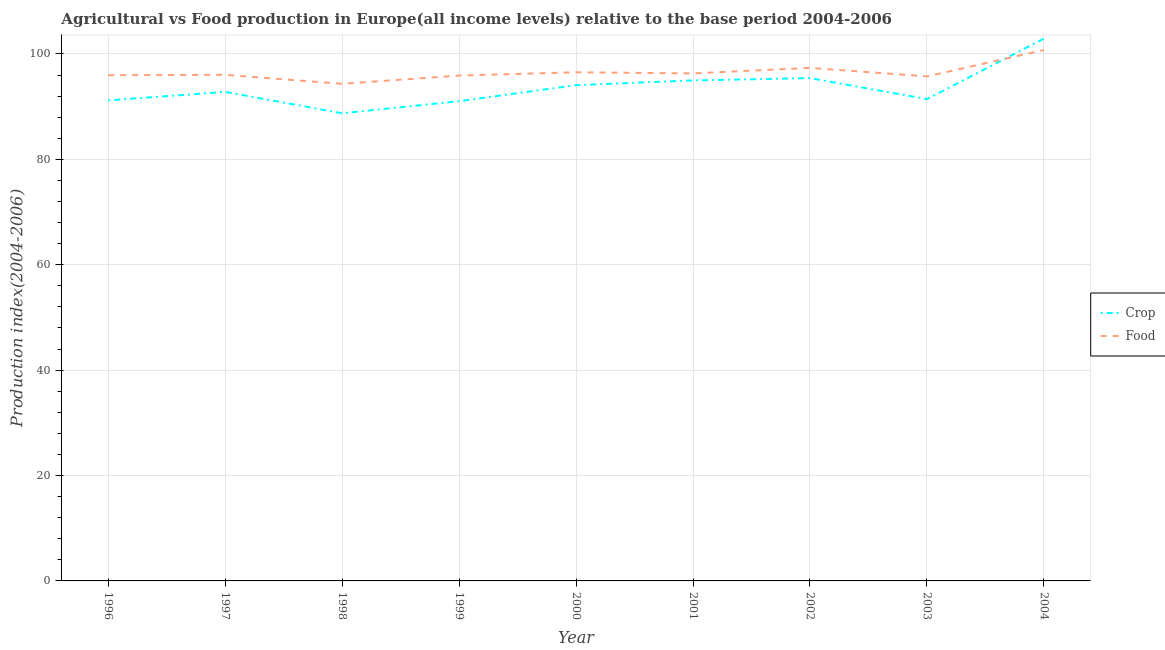How many different coloured lines are there?
Provide a short and direct response. 2. What is the food production index in 1996?
Ensure brevity in your answer.  95.96. Across all years, what is the maximum crop production index?
Give a very brief answer. 102.91. Across all years, what is the minimum food production index?
Provide a succinct answer. 94.32. What is the total food production index in the graph?
Your answer should be very brief. 868.87. What is the difference between the food production index in 1996 and that in 2004?
Keep it short and to the point. -4.79. What is the difference between the crop production index in 2001 and the food production index in 1999?
Offer a terse response. -0.92. What is the average food production index per year?
Offer a very short reply. 96.54. In the year 2004, what is the difference between the crop production index and food production index?
Ensure brevity in your answer.  2.16. In how many years, is the crop production index greater than 36?
Make the answer very short. 9. What is the ratio of the crop production index in 2001 to that in 2002?
Keep it short and to the point. 1. Is the food production index in 1996 less than that in 2002?
Make the answer very short. Yes. Is the difference between the crop production index in 1999 and 2000 greater than the difference between the food production index in 1999 and 2000?
Your answer should be very brief. No. What is the difference between the highest and the second highest food production index?
Your answer should be very brief. 3.39. What is the difference between the highest and the lowest crop production index?
Your answer should be compact. 14.17. In how many years, is the food production index greater than the average food production index taken over all years?
Your answer should be compact. 2. Does the crop production index monotonically increase over the years?
Your answer should be compact. No. Is the crop production index strictly less than the food production index over the years?
Provide a succinct answer. No. How many lines are there?
Your answer should be compact. 2. What is the difference between two consecutive major ticks on the Y-axis?
Provide a succinct answer. 20. Does the graph contain any zero values?
Make the answer very short. No. Does the graph contain grids?
Offer a terse response. Yes. How are the legend labels stacked?
Ensure brevity in your answer.  Vertical. What is the title of the graph?
Your answer should be compact. Agricultural vs Food production in Europe(all income levels) relative to the base period 2004-2006. Does "Long-term debt" appear as one of the legend labels in the graph?
Your response must be concise. No. What is the label or title of the X-axis?
Give a very brief answer. Year. What is the label or title of the Y-axis?
Ensure brevity in your answer.  Production index(2004-2006). What is the Production index(2004-2006) of Crop in 1996?
Make the answer very short. 91.18. What is the Production index(2004-2006) of Food in 1996?
Your answer should be very brief. 95.96. What is the Production index(2004-2006) in Crop in 1997?
Provide a short and direct response. 92.79. What is the Production index(2004-2006) in Food in 1997?
Make the answer very short. 96.04. What is the Production index(2004-2006) in Crop in 1998?
Your answer should be very brief. 88.74. What is the Production index(2004-2006) of Food in 1998?
Provide a short and direct response. 94.32. What is the Production index(2004-2006) in Crop in 1999?
Ensure brevity in your answer.  91.03. What is the Production index(2004-2006) in Food in 1999?
Keep it short and to the point. 95.89. What is the Production index(2004-2006) in Crop in 2000?
Provide a short and direct response. 94.07. What is the Production index(2004-2006) in Food in 2000?
Your answer should be compact. 96.52. What is the Production index(2004-2006) in Crop in 2001?
Your response must be concise. 94.97. What is the Production index(2004-2006) in Food in 2001?
Make the answer very short. 96.3. What is the Production index(2004-2006) in Crop in 2002?
Your answer should be very brief. 95.41. What is the Production index(2004-2006) in Food in 2002?
Provide a short and direct response. 97.35. What is the Production index(2004-2006) in Crop in 2003?
Your answer should be compact. 91.42. What is the Production index(2004-2006) in Food in 2003?
Offer a very short reply. 95.74. What is the Production index(2004-2006) of Crop in 2004?
Provide a short and direct response. 102.91. What is the Production index(2004-2006) of Food in 2004?
Ensure brevity in your answer.  100.75. Across all years, what is the maximum Production index(2004-2006) in Crop?
Make the answer very short. 102.91. Across all years, what is the maximum Production index(2004-2006) in Food?
Provide a succinct answer. 100.75. Across all years, what is the minimum Production index(2004-2006) in Crop?
Keep it short and to the point. 88.74. Across all years, what is the minimum Production index(2004-2006) of Food?
Offer a very short reply. 94.32. What is the total Production index(2004-2006) of Crop in the graph?
Offer a very short reply. 842.54. What is the total Production index(2004-2006) of Food in the graph?
Your answer should be compact. 868.87. What is the difference between the Production index(2004-2006) in Crop in 1996 and that in 1997?
Provide a short and direct response. -1.61. What is the difference between the Production index(2004-2006) in Food in 1996 and that in 1997?
Provide a succinct answer. -0.08. What is the difference between the Production index(2004-2006) in Crop in 1996 and that in 1998?
Provide a short and direct response. 2.44. What is the difference between the Production index(2004-2006) of Food in 1996 and that in 1998?
Provide a succinct answer. 1.64. What is the difference between the Production index(2004-2006) in Crop in 1996 and that in 1999?
Make the answer very short. 0.15. What is the difference between the Production index(2004-2006) in Food in 1996 and that in 1999?
Your answer should be very brief. 0.07. What is the difference between the Production index(2004-2006) of Crop in 1996 and that in 2000?
Provide a short and direct response. -2.89. What is the difference between the Production index(2004-2006) in Food in 1996 and that in 2000?
Keep it short and to the point. -0.56. What is the difference between the Production index(2004-2006) in Crop in 1996 and that in 2001?
Ensure brevity in your answer.  -3.79. What is the difference between the Production index(2004-2006) of Food in 1996 and that in 2001?
Give a very brief answer. -0.34. What is the difference between the Production index(2004-2006) of Crop in 1996 and that in 2002?
Make the answer very short. -4.23. What is the difference between the Production index(2004-2006) in Food in 1996 and that in 2002?
Provide a short and direct response. -1.39. What is the difference between the Production index(2004-2006) of Crop in 1996 and that in 2003?
Provide a short and direct response. -0.24. What is the difference between the Production index(2004-2006) of Food in 1996 and that in 2003?
Provide a succinct answer. 0.22. What is the difference between the Production index(2004-2006) in Crop in 1996 and that in 2004?
Provide a succinct answer. -11.72. What is the difference between the Production index(2004-2006) of Food in 1996 and that in 2004?
Provide a succinct answer. -4.79. What is the difference between the Production index(2004-2006) in Crop in 1997 and that in 1998?
Offer a very short reply. 4.05. What is the difference between the Production index(2004-2006) of Food in 1997 and that in 1998?
Provide a short and direct response. 1.71. What is the difference between the Production index(2004-2006) in Crop in 1997 and that in 1999?
Keep it short and to the point. 1.76. What is the difference between the Production index(2004-2006) of Food in 1997 and that in 1999?
Your answer should be very brief. 0.14. What is the difference between the Production index(2004-2006) in Crop in 1997 and that in 2000?
Offer a very short reply. -1.28. What is the difference between the Production index(2004-2006) of Food in 1997 and that in 2000?
Your answer should be compact. -0.48. What is the difference between the Production index(2004-2006) of Crop in 1997 and that in 2001?
Give a very brief answer. -2.18. What is the difference between the Production index(2004-2006) in Food in 1997 and that in 2001?
Offer a terse response. -0.27. What is the difference between the Production index(2004-2006) in Crop in 1997 and that in 2002?
Your answer should be very brief. -2.62. What is the difference between the Production index(2004-2006) in Food in 1997 and that in 2002?
Provide a short and direct response. -1.31. What is the difference between the Production index(2004-2006) in Crop in 1997 and that in 2003?
Give a very brief answer. 1.37. What is the difference between the Production index(2004-2006) in Food in 1997 and that in 2003?
Your response must be concise. 0.3. What is the difference between the Production index(2004-2006) in Crop in 1997 and that in 2004?
Ensure brevity in your answer.  -10.11. What is the difference between the Production index(2004-2006) in Food in 1997 and that in 2004?
Provide a succinct answer. -4.71. What is the difference between the Production index(2004-2006) in Crop in 1998 and that in 1999?
Your response must be concise. -2.29. What is the difference between the Production index(2004-2006) of Food in 1998 and that in 1999?
Your answer should be very brief. -1.57. What is the difference between the Production index(2004-2006) of Crop in 1998 and that in 2000?
Your answer should be compact. -5.33. What is the difference between the Production index(2004-2006) in Food in 1998 and that in 2000?
Your response must be concise. -2.19. What is the difference between the Production index(2004-2006) in Crop in 1998 and that in 2001?
Offer a terse response. -6.23. What is the difference between the Production index(2004-2006) of Food in 1998 and that in 2001?
Offer a very short reply. -1.98. What is the difference between the Production index(2004-2006) of Crop in 1998 and that in 2002?
Make the answer very short. -6.67. What is the difference between the Production index(2004-2006) of Food in 1998 and that in 2002?
Give a very brief answer. -3.03. What is the difference between the Production index(2004-2006) in Crop in 1998 and that in 2003?
Your answer should be very brief. -2.68. What is the difference between the Production index(2004-2006) of Food in 1998 and that in 2003?
Offer a very short reply. -1.41. What is the difference between the Production index(2004-2006) in Crop in 1998 and that in 2004?
Your response must be concise. -14.17. What is the difference between the Production index(2004-2006) of Food in 1998 and that in 2004?
Provide a short and direct response. -6.42. What is the difference between the Production index(2004-2006) of Crop in 1999 and that in 2000?
Keep it short and to the point. -3.04. What is the difference between the Production index(2004-2006) in Food in 1999 and that in 2000?
Provide a succinct answer. -0.62. What is the difference between the Production index(2004-2006) in Crop in 1999 and that in 2001?
Make the answer very short. -3.94. What is the difference between the Production index(2004-2006) of Food in 1999 and that in 2001?
Ensure brevity in your answer.  -0.41. What is the difference between the Production index(2004-2006) of Crop in 1999 and that in 2002?
Your response must be concise. -4.38. What is the difference between the Production index(2004-2006) of Food in 1999 and that in 2002?
Provide a succinct answer. -1.46. What is the difference between the Production index(2004-2006) in Crop in 1999 and that in 2003?
Give a very brief answer. -0.39. What is the difference between the Production index(2004-2006) of Food in 1999 and that in 2003?
Ensure brevity in your answer.  0.16. What is the difference between the Production index(2004-2006) in Crop in 1999 and that in 2004?
Ensure brevity in your answer.  -11.87. What is the difference between the Production index(2004-2006) of Food in 1999 and that in 2004?
Give a very brief answer. -4.85. What is the difference between the Production index(2004-2006) of Crop in 2000 and that in 2001?
Give a very brief answer. -0.9. What is the difference between the Production index(2004-2006) of Food in 2000 and that in 2001?
Ensure brevity in your answer.  0.21. What is the difference between the Production index(2004-2006) in Crop in 2000 and that in 2002?
Ensure brevity in your answer.  -1.34. What is the difference between the Production index(2004-2006) of Food in 2000 and that in 2002?
Ensure brevity in your answer.  -0.83. What is the difference between the Production index(2004-2006) in Crop in 2000 and that in 2003?
Give a very brief answer. 2.65. What is the difference between the Production index(2004-2006) of Food in 2000 and that in 2003?
Offer a terse response. 0.78. What is the difference between the Production index(2004-2006) of Crop in 2000 and that in 2004?
Your response must be concise. -8.84. What is the difference between the Production index(2004-2006) in Food in 2000 and that in 2004?
Provide a short and direct response. -4.23. What is the difference between the Production index(2004-2006) in Crop in 2001 and that in 2002?
Your answer should be very brief. -0.44. What is the difference between the Production index(2004-2006) of Food in 2001 and that in 2002?
Your response must be concise. -1.05. What is the difference between the Production index(2004-2006) of Crop in 2001 and that in 2003?
Give a very brief answer. 3.55. What is the difference between the Production index(2004-2006) of Food in 2001 and that in 2003?
Make the answer very short. 0.57. What is the difference between the Production index(2004-2006) of Crop in 2001 and that in 2004?
Your response must be concise. -7.93. What is the difference between the Production index(2004-2006) of Food in 2001 and that in 2004?
Offer a very short reply. -4.44. What is the difference between the Production index(2004-2006) in Crop in 2002 and that in 2003?
Provide a short and direct response. 3.99. What is the difference between the Production index(2004-2006) in Food in 2002 and that in 2003?
Provide a succinct answer. 1.62. What is the difference between the Production index(2004-2006) in Crop in 2002 and that in 2004?
Offer a terse response. -7.5. What is the difference between the Production index(2004-2006) of Food in 2002 and that in 2004?
Your response must be concise. -3.39. What is the difference between the Production index(2004-2006) of Crop in 2003 and that in 2004?
Provide a succinct answer. -11.48. What is the difference between the Production index(2004-2006) in Food in 2003 and that in 2004?
Your answer should be compact. -5.01. What is the difference between the Production index(2004-2006) of Crop in 1996 and the Production index(2004-2006) of Food in 1997?
Your answer should be compact. -4.85. What is the difference between the Production index(2004-2006) of Crop in 1996 and the Production index(2004-2006) of Food in 1998?
Provide a succinct answer. -3.14. What is the difference between the Production index(2004-2006) of Crop in 1996 and the Production index(2004-2006) of Food in 1999?
Make the answer very short. -4.71. What is the difference between the Production index(2004-2006) of Crop in 1996 and the Production index(2004-2006) of Food in 2000?
Offer a terse response. -5.33. What is the difference between the Production index(2004-2006) of Crop in 1996 and the Production index(2004-2006) of Food in 2001?
Your response must be concise. -5.12. What is the difference between the Production index(2004-2006) in Crop in 1996 and the Production index(2004-2006) in Food in 2002?
Make the answer very short. -6.17. What is the difference between the Production index(2004-2006) in Crop in 1996 and the Production index(2004-2006) in Food in 2003?
Provide a succinct answer. -4.55. What is the difference between the Production index(2004-2006) of Crop in 1996 and the Production index(2004-2006) of Food in 2004?
Offer a very short reply. -9.56. What is the difference between the Production index(2004-2006) of Crop in 1997 and the Production index(2004-2006) of Food in 1998?
Offer a terse response. -1.53. What is the difference between the Production index(2004-2006) in Crop in 1997 and the Production index(2004-2006) in Food in 1999?
Provide a succinct answer. -3.1. What is the difference between the Production index(2004-2006) of Crop in 1997 and the Production index(2004-2006) of Food in 2000?
Keep it short and to the point. -3.72. What is the difference between the Production index(2004-2006) in Crop in 1997 and the Production index(2004-2006) in Food in 2001?
Keep it short and to the point. -3.51. What is the difference between the Production index(2004-2006) of Crop in 1997 and the Production index(2004-2006) of Food in 2002?
Your response must be concise. -4.56. What is the difference between the Production index(2004-2006) of Crop in 1997 and the Production index(2004-2006) of Food in 2003?
Your answer should be very brief. -2.94. What is the difference between the Production index(2004-2006) in Crop in 1997 and the Production index(2004-2006) in Food in 2004?
Give a very brief answer. -7.95. What is the difference between the Production index(2004-2006) in Crop in 1998 and the Production index(2004-2006) in Food in 1999?
Ensure brevity in your answer.  -7.15. What is the difference between the Production index(2004-2006) of Crop in 1998 and the Production index(2004-2006) of Food in 2000?
Your answer should be compact. -7.78. What is the difference between the Production index(2004-2006) of Crop in 1998 and the Production index(2004-2006) of Food in 2001?
Keep it short and to the point. -7.56. What is the difference between the Production index(2004-2006) of Crop in 1998 and the Production index(2004-2006) of Food in 2002?
Offer a terse response. -8.61. What is the difference between the Production index(2004-2006) of Crop in 1998 and the Production index(2004-2006) of Food in 2003?
Your answer should be compact. -7. What is the difference between the Production index(2004-2006) in Crop in 1998 and the Production index(2004-2006) in Food in 2004?
Give a very brief answer. -12.01. What is the difference between the Production index(2004-2006) in Crop in 1999 and the Production index(2004-2006) in Food in 2000?
Your response must be concise. -5.49. What is the difference between the Production index(2004-2006) in Crop in 1999 and the Production index(2004-2006) in Food in 2001?
Give a very brief answer. -5.27. What is the difference between the Production index(2004-2006) of Crop in 1999 and the Production index(2004-2006) of Food in 2002?
Make the answer very short. -6.32. What is the difference between the Production index(2004-2006) of Crop in 1999 and the Production index(2004-2006) of Food in 2003?
Give a very brief answer. -4.7. What is the difference between the Production index(2004-2006) in Crop in 1999 and the Production index(2004-2006) in Food in 2004?
Keep it short and to the point. -9.71. What is the difference between the Production index(2004-2006) of Crop in 2000 and the Production index(2004-2006) of Food in 2001?
Your answer should be very brief. -2.23. What is the difference between the Production index(2004-2006) of Crop in 2000 and the Production index(2004-2006) of Food in 2002?
Make the answer very short. -3.28. What is the difference between the Production index(2004-2006) in Crop in 2000 and the Production index(2004-2006) in Food in 2003?
Ensure brevity in your answer.  -1.66. What is the difference between the Production index(2004-2006) in Crop in 2000 and the Production index(2004-2006) in Food in 2004?
Your answer should be compact. -6.67. What is the difference between the Production index(2004-2006) in Crop in 2001 and the Production index(2004-2006) in Food in 2002?
Your answer should be very brief. -2.38. What is the difference between the Production index(2004-2006) in Crop in 2001 and the Production index(2004-2006) in Food in 2003?
Offer a terse response. -0.76. What is the difference between the Production index(2004-2006) of Crop in 2001 and the Production index(2004-2006) of Food in 2004?
Make the answer very short. -5.77. What is the difference between the Production index(2004-2006) of Crop in 2002 and the Production index(2004-2006) of Food in 2003?
Offer a terse response. -0.32. What is the difference between the Production index(2004-2006) of Crop in 2002 and the Production index(2004-2006) of Food in 2004?
Your answer should be very brief. -5.33. What is the difference between the Production index(2004-2006) in Crop in 2003 and the Production index(2004-2006) in Food in 2004?
Give a very brief answer. -9.32. What is the average Production index(2004-2006) in Crop per year?
Offer a very short reply. 93.62. What is the average Production index(2004-2006) in Food per year?
Give a very brief answer. 96.54. In the year 1996, what is the difference between the Production index(2004-2006) in Crop and Production index(2004-2006) in Food?
Offer a terse response. -4.78. In the year 1997, what is the difference between the Production index(2004-2006) of Crop and Production index(2004-2006) of Food?
Your answer should be compact. -3.24. In the year 1998, what is the difference between the Production index(2004-2006) in Crop and Production index(2004-2006) in Food?
Provide a short and direct response. -5.58. In the year 1999, what is the difference between the Production index(2004-2006) of Crop and Production index(2004-2006) of Food?
Ensure brevity in your answer.  -4.86. In the year 2000, what is the difference between the Production index(2004-2006) in Crop and Production index(2004-2006) in Food?
Keep it short and to the point. -2.45. In the year 2001, what is the difference between the Production index(2004-2006) of Crop and Production index(2004-2006) of Food?
Your response must be concise. -1.33. In the year 2002, what is the difference between the Production index(2004-2006) of Crop and Production index(2004-2006) of Food?
Offer a terse response. -1.94. In the year 2003, what is the difference between the Production index(2004-2006) in Crop and Production index(2004-2006) in Food?
Your answer should be very brief. -4.31. In the year 2004, what is the difference between the Production index(2004-2006) of Crop and Production index(2004-2006) of Food?
Your answer should be very brief. 2.16. What is the ratio of the Production index(2004-2006) of Crop in 1996 to that in 1997?
Your answer should be very brief. 0.98. What is the ratio of the Production index(2004-2006) in Crop in 1996 to that in 1998?
Keep it short and to the point. 1.03. What is the ratio of the Production index(2004-2006) in Food in 1996 to that in 1998?
Your answer should be very brief. 1.02. What is the ratio of the Production index(2004-2006) of Crop in 1996 to that in 2000?
Ensure brevity in your answer.  0.97. What is the ratio of the Production index(2004-2006) of Food in 1996 to that in 2000?
Ensure brevity in your answer.  0.99. What is the ratio of the Production index(2004-2006) of Crop in 1996 to that in 2001?
Make the answer very short. 0.96. What is the ratio of the Production index(2004-2006) in Food in 1996 to that in 2001?
Make the answer very short. 1. What is the ratio of the Production index(2004-2006) in Crop in 1996 to that in 2002?
Ensure brevity in your answer.  0.96. What is the ratio of the Production index(2004-2006) in Food in 1996 to that in 2002?
Your answer should be very brief. 0.99. What is the ratio of the Production index(2004-2006) in Crop in 1996 to that in 2003?
Your answer should be very brief. 1. What is the ratio of the Production index(2004-2006) of Crop in 1996 to that in 2004?
Offer a very short reply. 0.89. What is the ratio of the Production index(2004-2006) in Food in 1996 to that in 2004?
Your answer should be compact. 0.95. What is the ratio of the Production index(2004-2006) in Crop in 1997 to that in 1998?
Offer a very short reply. 1.05. What is the ratio of the Production index(2004-2006) of Food in 1997 to that in 1998?
Your answer should be very brief. 1.02. What is the ratio of the Production index(2004-2006) of Crop in 1997 to that in 1999?
Give a very brief answer. 1.02. What is the ratio of the Production index(2004-2006) of Food in 1997 to that in 1999?
Provide a succinct answer. 1. What is the ratio of the Production index(2004-2006) of Crop in 1997 to that in 2000?
Keep it short and to the point. 0.99. What is the ratio of the Production index(2004-2006) of Crop in 1997 to that in 2001?
Make the answer very short. 0.98. What is the ratio of the Production index(2004-2006) of Crop in 1997 to that in 2002?
Offer a terse response. 0.97. What is the ratio of the Production index(2004-2006) in Food in 1997 to that in 2002?
Keep it short and to the point. 0.99. What is the ratio of the Production index(2004-2006) in Food in 1997 to that in 2003?
Offer a very short reply. 1. What is the ratio of the Production index(2004-2006) of Crop in 1997 to that in 2004?
Give a very brief answer. 0.9. What is the ratio of the Production index(2004-2006) in Food in 1997 to that in 2004?
Your answer should be compact. 0.95. What is the ratio of the Production index(2004-2006) in Crop in 1998 to that in 1999?
Your answer should be very brief. 0.97. What is the ratio of the Production index(2004-2006) of Food in 1998 to that in 1999?
Your answer should be very brief. 0.98. What is the ratio of the Production index(2004-2006) in Crop in 1998 to that in 2000?
Your response must be concise. 0.94. What is the ratio of the Production index(2004-2006) in Food in 1998 to that in 2000?
Ensure brevity in your answer.  0.98. What is the ratio of the Production index(2004-2006) in Crop in 1998 to that in 2001?
Your response must be concise. 0.93. What is the ratio of the Production index(2004-2006) in Food in 1998 to that in 2001?
Keep it short and to the point. 0.98. What is the ratio of the Production index(2004-2006) of Crop in 1998 to that in 2002?
Your answer should be compact. 0.93. What is the ratio of the Production index(2004-2006) in Food in 1998 to that in 2002?
Offer a terse response. 0.97. What is the ratio of the Production index(2004-2006) of Crop in 1998 to that in 2003?
Give a very brief answer. 0.97. What is the ratio of the Production index(2004-2006) in Food in 1998 to that in 2003?
Provide a succinct answer. 0.99. What is the ratio of the Production index(2004-2006) of Crop in 1998 to that in 2004?
Keep it short and to the point. 0.86. What is the ratio of the Production index(2004-2006) in Food in 1998 to that in 2004?
Ensure brevity in your answer.  0.94. What is the ratio of the Production index(2004-2006) of Crop in 1999 to that in 2001?
Ensure brevity in your answer.  0.96. What is the ratio of the Production index(2004-2006) in Food in 1999 to that in 2001?
Provide a short and direct response. 1. What is the ratio of the Production index(2004-2006) in Crop in 1999 to that in 2002?
Give a very brief answer. 0.95. What is the ratio of the Production index(2004-2006) of Food in 1999 to that in 2002?
Provide a succinct answer. 0.98. What is the ratio of the Production index(2004-2006) of Crop in 1999 to that in 2003?
Ensure brevity in your answer.  1. What is the ratio of the Production index(2004-2006) of Food in 1999 to that in 2003?
Ensure brevity in your answer.  1. What is the ratio of the Production index(2004-2006) in Crop in 1999 to that in 2004?
Provide a short and direct response. 0.88. What is the ratio of the Production index(2004-2006) in Food in 1999 to that in 2004?
Provide a succinct answer. 0.95. What is the ratio of the Production index(2004-2006) of Crop in 2000 to that in 2002?
Offer a very short reply. 0.99. What is the ratio of the Production index(2004-2006) in Food in 2000 to that in 2002?
Provide a succinct answer. 0.99. What is the ratio of the Production index(2004-2006) of Crop in 2000 to that in 2003?
Make the answer very short. 1.03. What is the ratio of the Production index(2004-2006) of Food in 2000 to that in 2003?
Your answer should be compact. 1.01. What is the ratio of the Production index(2004-2006) in Crop in 2000 to that in 2004?
Offer a terse response. 0.91. What is the ratio of the Production index(2004-2006) of Food in 2000 to that in 2004?
Your answer should be compact. 0.96. What is the ratio of the Production index(2004-2006) of Crop in 2001 to that in 2002?
Your answer should be very brief. 1. What is the ratio of the Production index(2004-2006) of Food in 2001 to that in 2002?
Your answer should be very brief. 0.99. What is the ratio of the Production index(2004-2006) in Crop in 2001 to that in 2003?
Provide a short and direct response. 1.04. What is the ratio of the Production index(2004-2006) in Food in 2001 to that in 2003?
Keep it short and to the point. 1.01. What is the ratio of the Production index(2004-2006) of Crop in 2001 to that in 2004?
Offer a terse response. 0.92. What is the ratio of the Production index(2004-2006) in Food in 2001 to that in 2004?
Keep it short and to the point. 0.96. What is the ratio of the Production index(2004-2006) of Crop in 2002 to that in 2003?
Ensure brevity in your answer.  1.04. What is the ratio of the Production index(2004-2006) in Food in 2002 to that in 2003?
Ensure brevity in your answer.  1.02. What is the ratio of the Production index(2004-2006) of Crop in 2002 to that in 2004?
Your answer should be compact. 0.93. What is the ratio of the Production index(2004-2006) of Food in 2002 to that in 2004?
Give a very brief answer. 0.97. What is the ratio of the Production index(2004-2006) of Crop in 2003 to that in 2004?
Ensure brevity in your answer.  0.89. What is the ratio of the Production index(2004-2006) in Food in 2003 to that in 2004?
Make the answer very short. 0.95. What is the difference between the highest and the second highest Production index(2004-2006) of Crop?
Your answer should be compact. 7.5. What is the difference between the highest and the second highest Production index(2004-2006) in Food?
Ensure brevity in your answer.  3.39. What is the difference between the highest and the lowest Production index(2004-2006) in Crop?
Ensure brevity in your answer.  14.17. What is the difference between the highest and the lowest Production index(2004-2006) of Food?
Give a very brief answer. 6.42. 